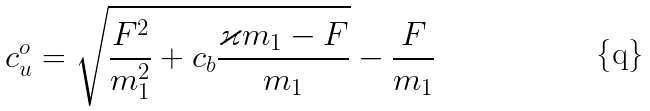<formula> <loc_0><loc_0><loc_500><loc_500>c _ { u } ^ { o } = \sqrt { \frac { F ^ { 2 } } { m _ { 1 } ^ { 2 } } + c _ { b } \frac { \varkappa m _ { 1 } - F } { m _ { 1 } } } - \frac { F } { m _ { 1 } }</formula> 